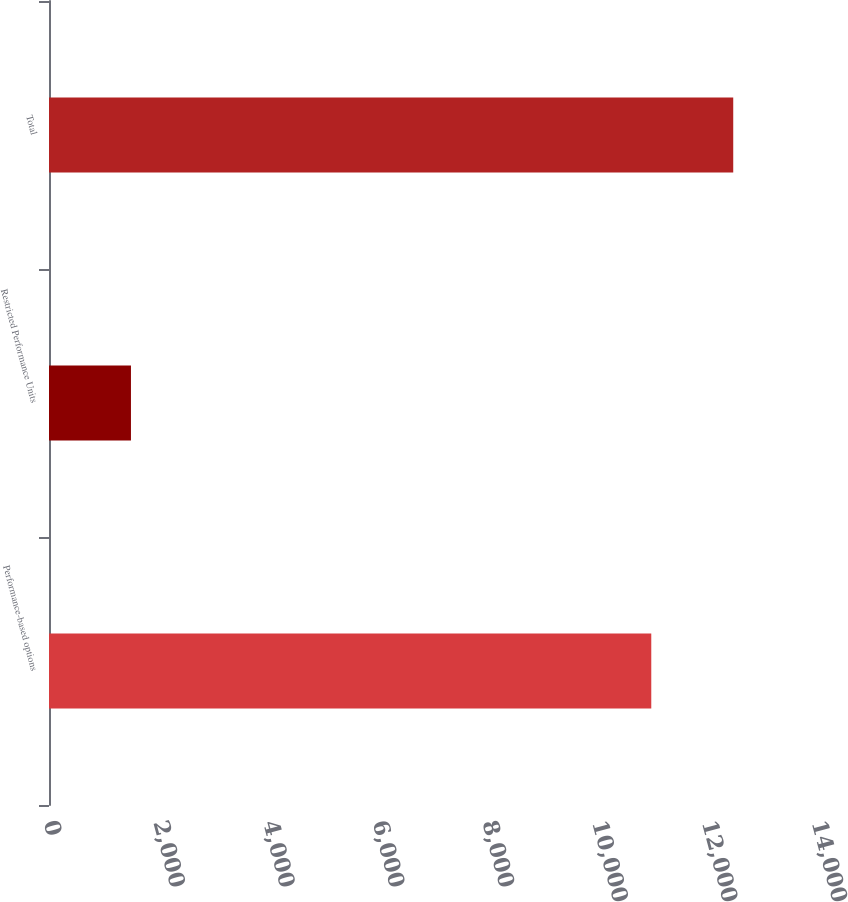Convert chart to OTSL. <chart><loc_0><loc_0><loc_500><loc_500><bar_chart><fcel>Performance-based options<fcel>Restricted Performance Units<fcel>Total<nl><fcel>10979<fcel>1494<fcel>12473<nl></chart> 